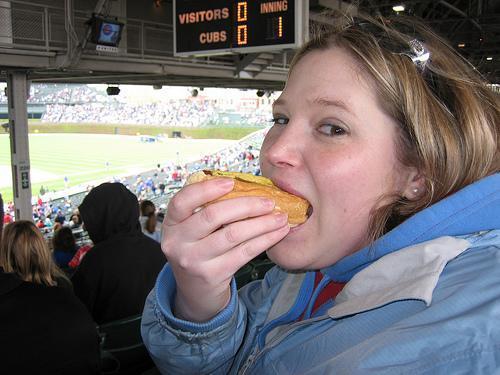How many people are there eating a hot dog?
Give a very brief answer. 1. 